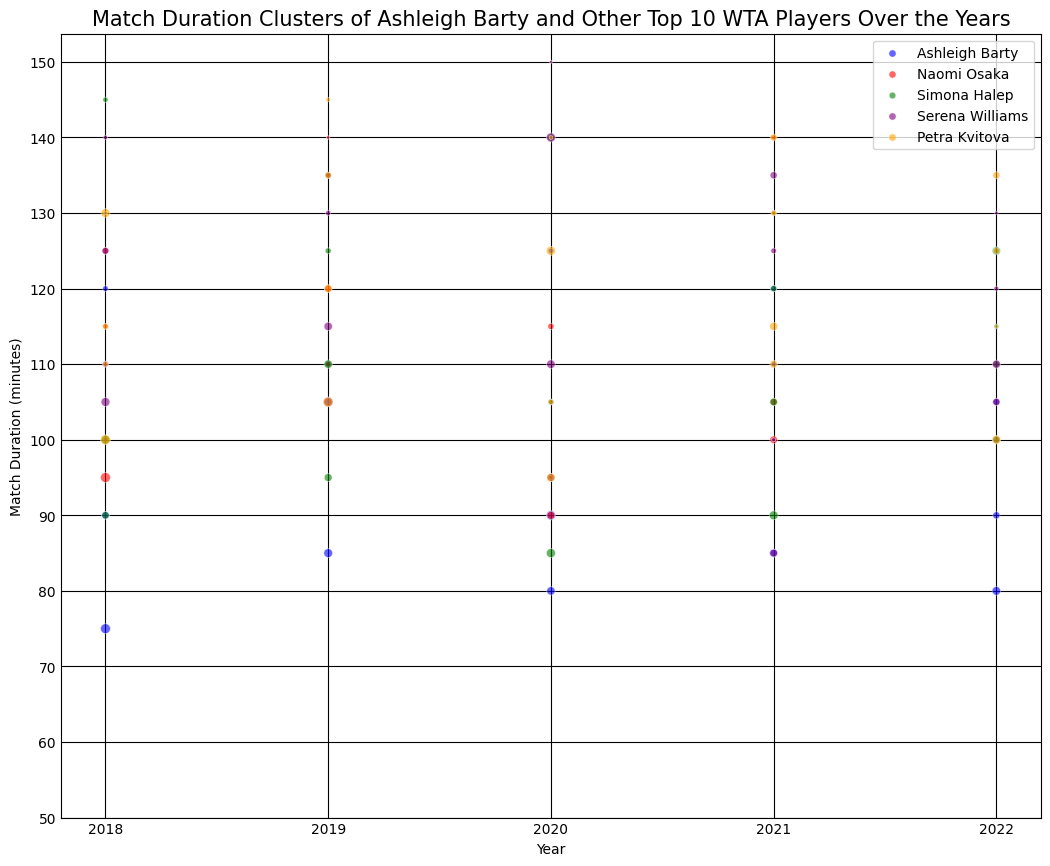What is the overall trend in match duration for Ashleigh Barty from 2018 to 2022? To determine the trend, we observe the scatter plot points for Ashleigh Barty across the years 2018 to 2022. We can see that there is some fluctuation in match durations. Overall, Ashleigh Barty's match durations seem to decrease slightly from 2018 to 2022 with some variations in between.
Answer: Slight decrease How does Ashleigh Barty's longest match duration compare to Naomi Osaka's longest match duration? Identify the maximum match duration for both players from the scatter plot. Ashleigh Barty's longest match duration appears to be around 140 minutes, while Naomi Osaka's longest match duration is around 150 minutes.
Answer: Naomi Osaka's is longer In which year did Ashleigh Barty have the most number of matches with durations above 100 minutes? Count the number of points above 100 minutes for each year for Ashleigh Barty. In 2019, Ashleigh Barty has multiple points above 100 minutes, suggesting it is the year with the most matches above that duration.
Answer: 2019 How does the match duration of Ashleigh Barty's 2021 matches compare to Simona Halep's 2021 matches? Compare the scatter plot points for Ashleigh Barty and Simona Halep in 2021. Ashleigh Barty's match durations mostly range between 85 and 120 minutes, while Simona Halep has a wider range between 90 and 130 minutes.
Answer: Halep's range is wider Identify the player with the shortest match duration in 2020 and state the duration. Check the scatter points in 2020 for all players. The shortest duration is around 80 minutes by Ashleigh Barty.
Answer: Ashleigh Barty, 80 minutes Which player consistently had longer matches than Ashleigh Barty from 2018 to 2022? Compare the overall distribution of match durations for each player to Ashleigh Barty. Serena Williams and Petra Kvitova generally have longer match durations compared to Ashleigh Barty.
Answer: Serena Williams and Petra Kvitova What is the average match duration for Ashleigh Barty in 2022? Sum the match durations of Ashleigh Barty in 2022 and divide by the number of matches in that year. The match durations are 90, 80, 105, and 100. The sum is 375, and there are 4 matches, so the average duration is 375/4 = 93.75 minutes.
Answer: 93.75 minutes How does the size of the markers correspond to the opponent rank for each player? Observe the marker sizes in the scatter plot. Larger markers represent higher opponent ranks and smaller markers represent lower ranks.
Answer: Larger markers have higher ranks 